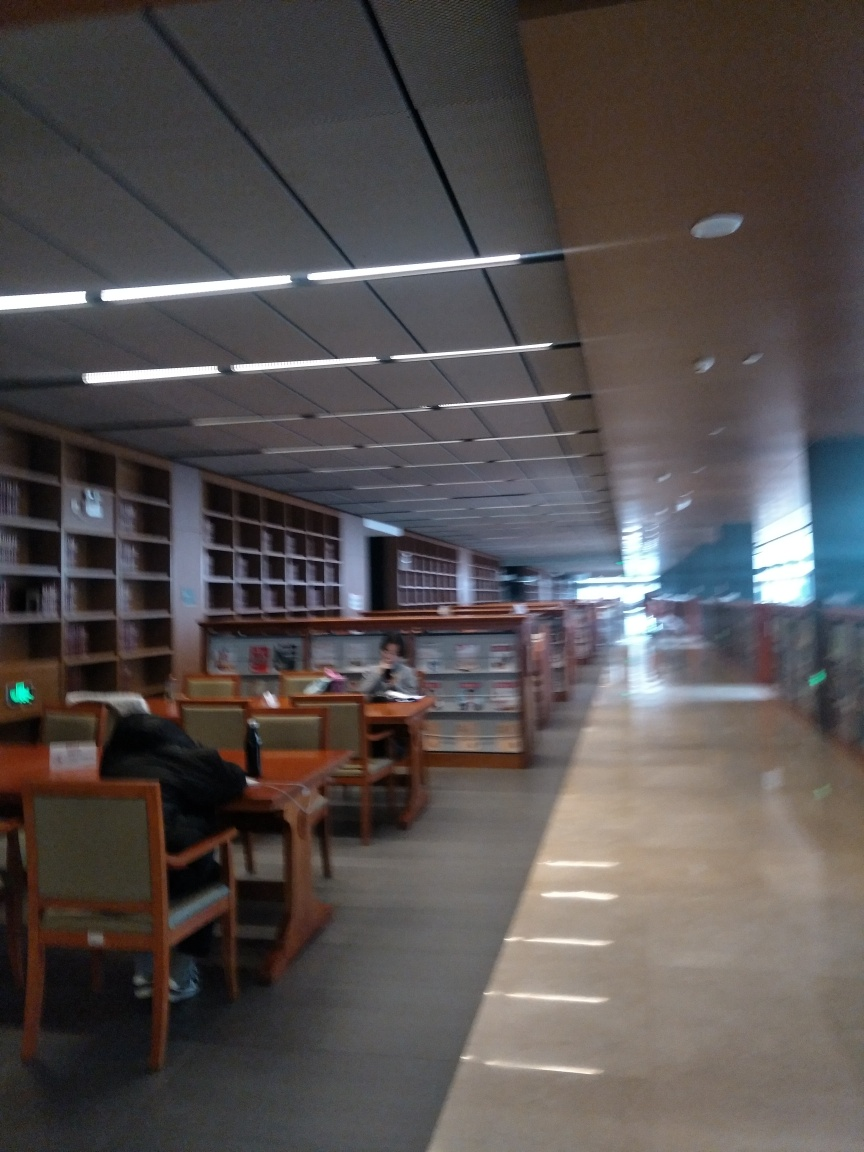What kind of place is shown in this image? The image displays a library interior, characterized by bookshelves, individual study tables, and a quiet atmosphere conducive to reading and research. Does it seem like a public or private space? It appears to be a public library, given the accessibility of the bookshelves and the layout of the studying areas designed for multiple users. 